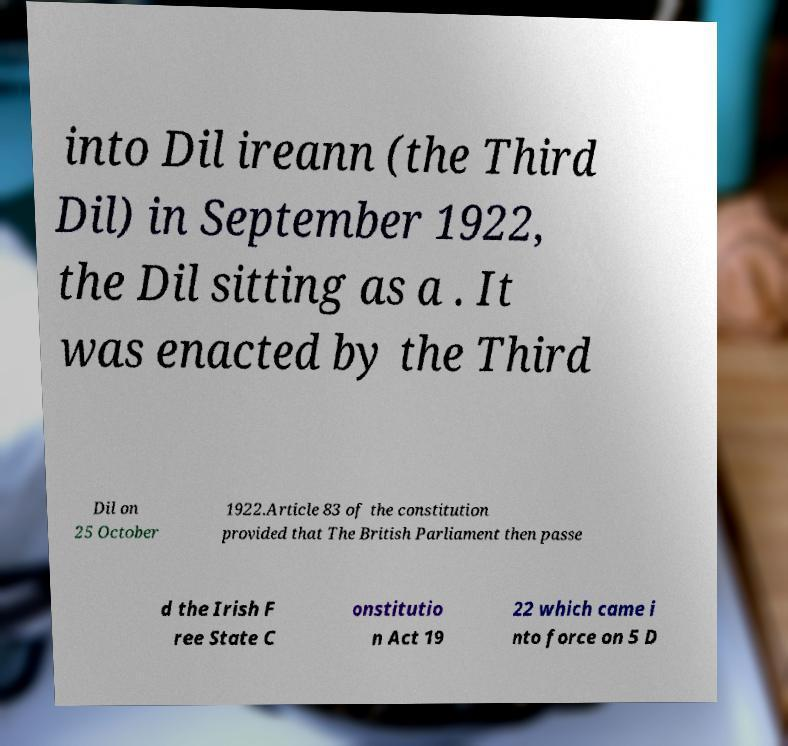Can you accurately transcribe the text from the provided image for me? into Dil ireann (the Third Dil) in September 1922, the Dil sitting as a . It was enacted by the Third Dil on 25 October 1922.Article 83 of the constitution provided that The British Parliament then passe d the Irish F ree State C onstitutio n Act 19 22 which came i nto force on 5 D 